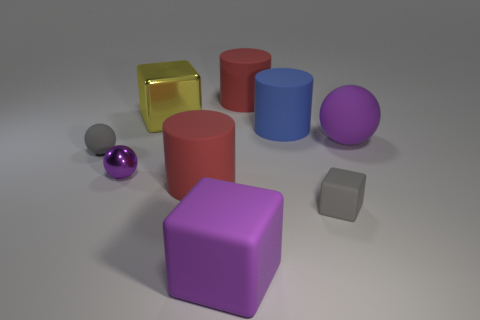How big is the purple object that is behind the small gray cube and in front of the large ball?
Ensure brevity in your answer.  Small. Does the red cylinder that is behind the yellow shiny thing have the same size as the small purple sphere?
Your answer should be very brief. No. Is there anything else of the same color as the metallic ball?
Your answer should be compact. Yes. Is the shape of the large blue thing the same as the red object that is behind the purple matte sphere?
Keep it short and to the point. Yes. There is a small thing that is to the right of the red cylinder right of the large purple matte thing on the left side of the big sphere; what shape is it?
Provide a succinct answer. Cube. Does the small block have the same color as the rubber sphere on the right side of the metallic ball?
Provide a short and direct response. No. What number of tiny rubber spheres are there?
Provide a short and direct response. 1. How many objects are either tiny rubber things or big purple rubber cubes?
Give a very brief answer. 3. The object that is the same color as the small matte cube is what size?
Provide a short and direct response. Small. Are there any matte objects to the left of the gray block?
Make the answer very short. Yes. 